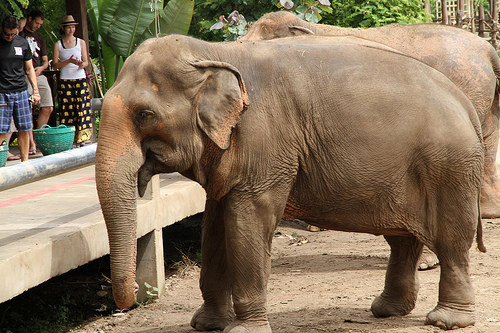What kind of animal is it? It is an elephant. 